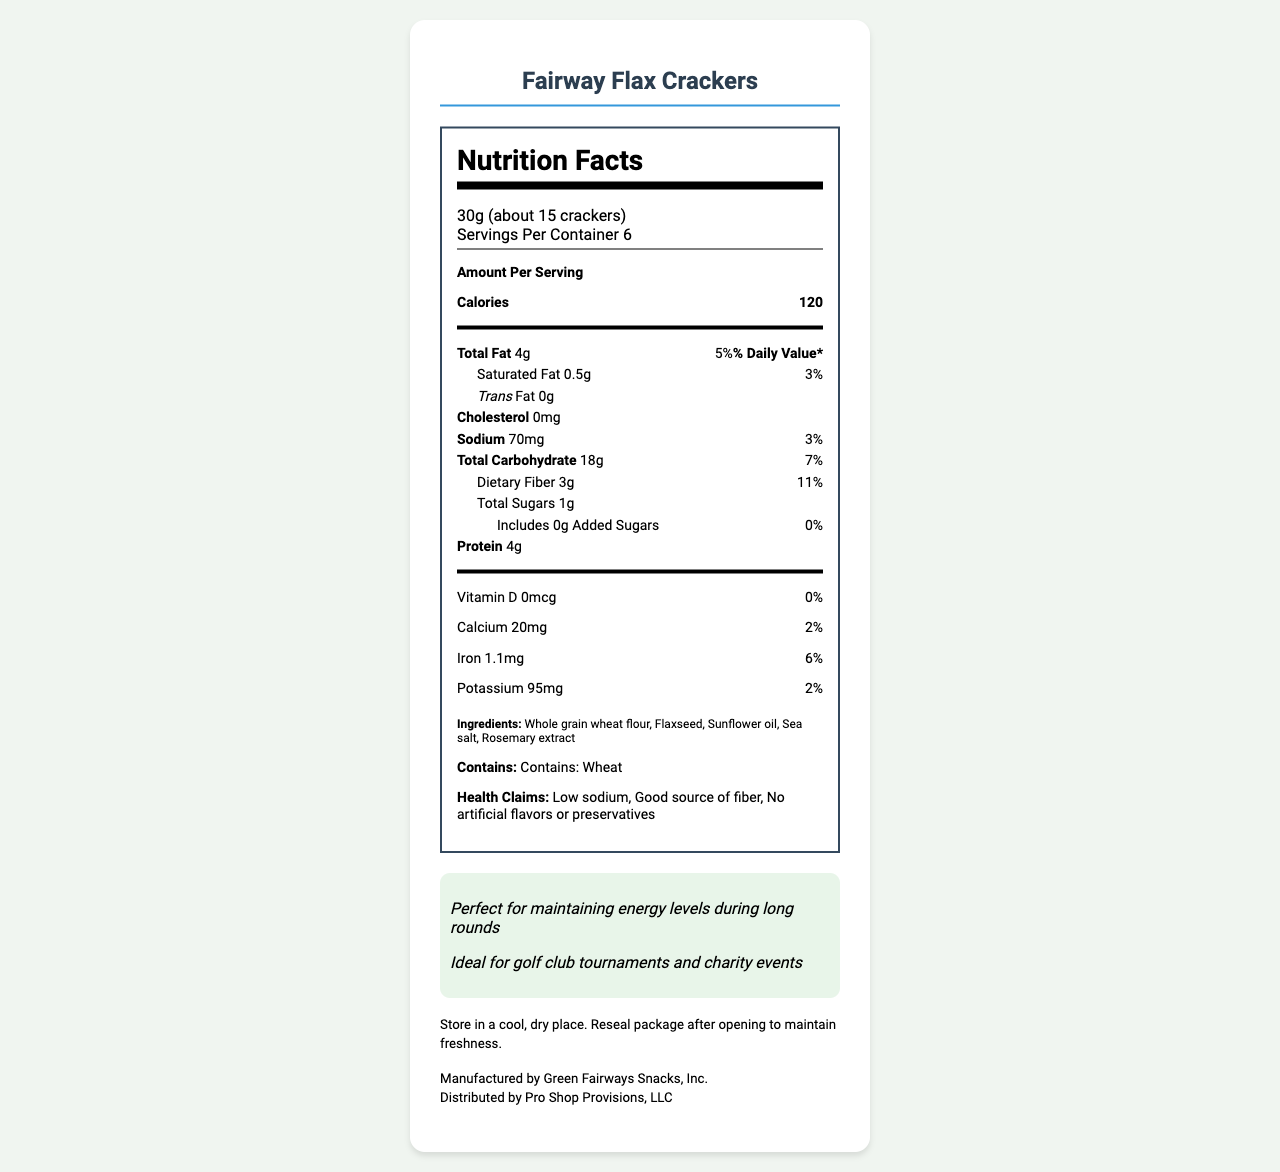what is the serving size? The serving size is stated in the document under "Serving Size".
Answer: 30g (about 15 crackers) how many calories are in one serving? The amount of calories per serving is listed as 120 in the "Amount Per Serving" section.
Answer: 120 how much sodium does one serving contain? The sodium content per serving is listed as 70mg in the nutrition label.
Answer: 70mg is there any trans fat in the Fairway Flax Crackers? The document lists trans fat content as 0g, meaning there is no trans fat.
Answer: No what are the main ingredients? The ingredients are listed in the "Ingredients" section.
Answer: Whole grain wheat flour, Flaxseed, Sunflower oil, Sea salt, Rosemary extract how much protein does one serving have? A. 2g B. 4g C. 6g D. 8g The nutrition label lists 4g of protein per serving.
Answer: B. 4g which claim is NOT made about these crackers? A. Organic B. Low sodium C. Good source of fiber D. No artificial flavors or preservatives The document lists "Low sodium", "Good source of fiber", and "No artificial flavors or preservatives" but does not mention "Organic".
Answer: A. Organic do these crackers contain any added sugars? The nutrition label indicates 0g of added sugars.
Answer: No is this snack suitable for people with allergies to wheat? The allergen information section clearly states that this product contains wheat.
Answer: No summarize the entire document or the main idea of the document. The document provides comprehensive nutritional information, including serving size, calorie content, fats, cholesterol, sodium, carbohydrates, fiber, sugars, protein, vitamins, and minerals. It also outlines the ingredients, allergen information, health claims, appeal for golfers, suitability for events, and storage instructions.
Answer: This document provides the nutrition facts and ingredients for Fairway Flax Crackers, which are marketed as a low-sodium snack option ideal for golf club events. It highlights key nutritional information, ingredient details, allergen info, health claims, storage instructions, and distribution details. what is the storage instruction for these crackers? The storage instructions are provided at the end of the document.
Answer: Store in a cool, dry place. Reseal package after opening to maintain freshness. who is the manufacturer and distributor of Fairway Flax Crackers? The document lists the manufacturer as Green Fairways Snacks, Inc. and the distributor as Pro Shop Provisions, LLC.
Answer: Manufactured by Green Fairways Snacks, Inc., Distributed by Pro Shop Provisions, LLC does the document state how many crackers are in one serving? The document specifies that one serving is about 15 crackers.
Answer: Yes what percent of the daily value of iron does one serving provide? A. 2% B. 4% C. 6% D. 8% The nutrition label indicates that one serving provides 6% of the daily value for iron.
Answer: C. 6% are there any artificial flavors or preservatives in these crackers? The health claims section states that there are no artificial flavors or preservatives.
Answer: No what kind of oil is used in these crackers? Sunflower oil is listed as one of the ingredients.
Answer: Sunflower oil does the document mention if these crackers are gluten-free? The document does not provide any information regarding whether the crackers are gluten-free.
Answer: No 